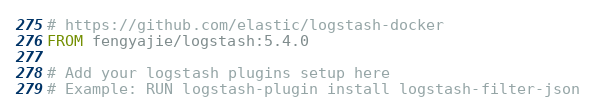<code> <loc_0><loc_0><loc_500><loc_500><_Dockerfile_># https://github.com/elastic/logstash-docker
FROM fengyajie/logstash:5.4.0

# Add your logstash plugins setup here
# Example: RUN logstash-plugin install logstash-filter-json
</code> 